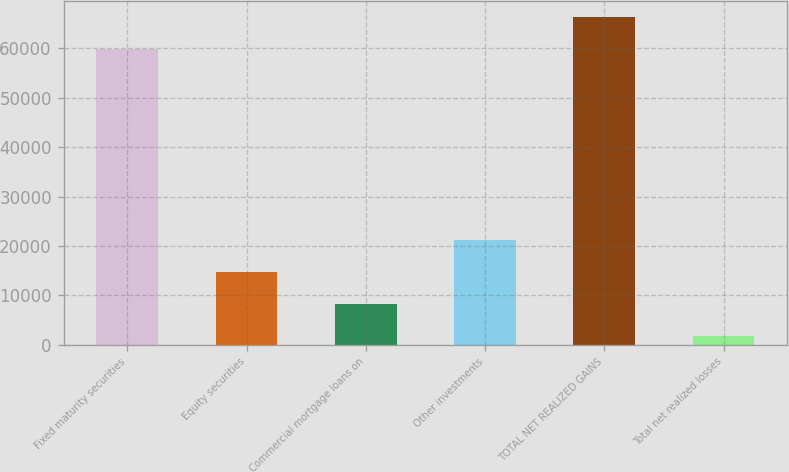<chart> <loc_0><loc_0><loc_500><loc_500><bar_chart><fcel>Fixed maturity securities<fcel>Equity securities<fcel>Commercial mortgage loans on<fcel>Other investments<fcel>TOTAL NET REALIZED GAINS<fcel>Total net realized losses<nl><fcel>59815<fcel>14713.6<fcel>8278.3<fcel>21148.9<fcel>66250.3<fcel>1843<nl></chart> 